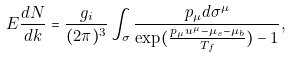<formula> <loc_0><loc_0><loc_500><loc_500>E \frac { d N } { d { k } } = \frac { g _ { i } } { ( 2 \pi ) ^ { 3 } } \int _ { \sigma } \frac { p _ { \mu } d \sigma ^ { \mu } } { \exp ( \frac { p _ { \mu } u ^ { \mu } - \mu _ { s } - \mu _ { b } } { T _ { f } } ) - 1 } ,</formula> 